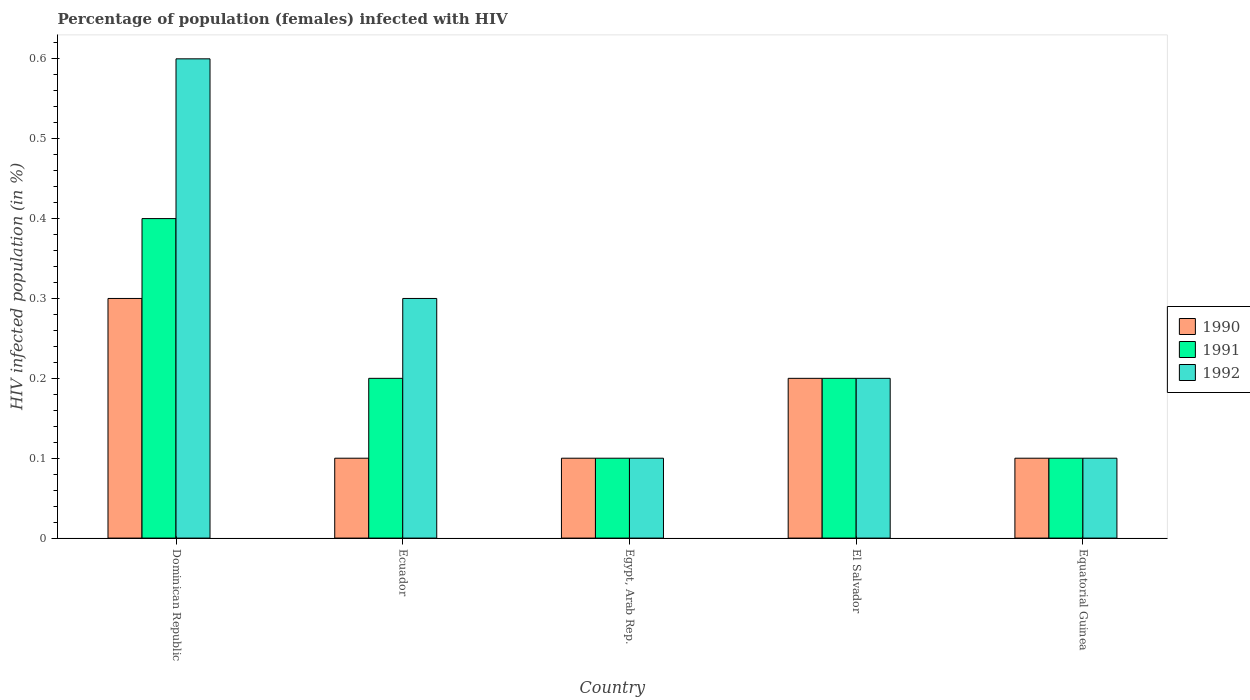How many different coloured bars are there?
Keep it short and to the point. 3. Are the number of bars on each tick of the X-axis equal?
Keep it short and to the point. Yes. What is the label of the 3rd group of bars from the left?
Provide a short and direct response. Egypt, Arab Rep. In how many cases, is the number of bars for a given country not equal to the number of legend labels?
Provide a short and direct response. 0. What is the percentage of HIV infected female population in 1990 in El Salvador?
Ensure brevity in your answer.  0.2. Across all countries, what is the maximum percentage of HIV infected female population in 1991?
Ensure brevity in your answer.  0.4. In which country was the percentage of HIV infected female population in 1990 maximum?
Provide a succinct answer. Dominican Republic. In which country was the percentage of HIV infected female population in 1992 minimum?
Provide a short and direct response. Egypt, Arab Rep. What is the difference between the percentage of HIV infected female population in 1991 in Dominican Republic and that in Ecuador?
Provide a succinct answer. 0.2. What is the difference between the percentage of HIV infected female population in 1991 in El Salvador and the percentage of HIV infected female population in 1992 in Dominican Republic?
Provide a short and direct response. -0.4. What is the average percentage of HIV infected female population in 1992 per country?
Offer a terse response. 0.26. What is the difference between the percentage of HIV infected female population of/in 1991 and percentage of HIV infected female population of/in 1992 in Dominican Republic?
Keep it short and to the point. -0.2. What is the ratio of the percentage of HIV infected female population in 1992 in Dominican Republic to that in Egypt, Arab Rep.?
Provide a succinct answer. 6. Is the percentage of HIV infected female population in 1990 in El Salvador less than that in Equatorial Guinea?
Your answer should be compact. No. What is the difference between the highest and the lowest percentage of HIV infected female population in 1991?
Your answer should be very brief. 0.3. In how many countries, is the percentage of HIV infected female population in 1991 greater than the average percentage of HIV infected female population in 1991 taken over all countries?
Provide a short and direct response. 1. Is it the case that in every country, the sum of the percentage of HIV infected female population in 1992 and percentage of HIV infected female population in 1991 is greater than the percentage of HIV infected female population in 1990?
Provide a succinct answer. Yes. How many bars are there?
Ensure brevity in your answer.  15. Are all the bars in the graph horizontal?
Your response must be concise. No. Are the values on the major ticks of Y-axis written in scientific E-notation?
Ensure brevity in your answer.  No. How are the legend labels stacked?
Your answer should be very brief. Vertical. What is the title of the graph?
Your answer should be very brief. Percentage of population (females) infected with HIV. Does "1964" appear as one of the legend labels in the graph?
Provide a short and direct response. No. What is the label or title of the Y-axis?
Ensure brevity in your answer.  HIV infected population (in %). What is the HIV infected population (in %) of 1990 in Dominican Republic?
Give a very brief answer. 0.3. What is the HIV infected population (in %) of 1992 in Ecuador?
Give a very brief answer. 0.3. What is the HIV infected population (in %) of 1990 in Egypt, Arab Rep.?
Provide a succinct answer. 0.1. What is the HIV infected population (in %) in 1991 in Egypt, Arab Rep.?
Your answer should be very brief. 0.1. What is the HIV infected population (in %) in 1992 in Egypt, Arab Rep.?
Your response must be concise. 0.1. What is the HIV infected population (in %) in 1990 in El Salvador?
Make the answer very short. 0.2. What is the HIV infected population (in %) of 1991 in El Salvador?
Your response must be concise. 0.2. What is the HIV infected population (in %) in 1992 in Equatorial Guinea?
Ensure brevity in your answer.  0.1. Across all countries, what is the maximum HIV infected population (in %) in 1990?
Ensure brevity in your answer.  0.3. Across all countries, what is the maximum HIV infected population (in %) of 1991?
Offer a terse response. 0.4. Across all countries, what is the minimum HIV infected population (in %) in 1990?
Provide a succinct answer. 0.1. Across all countries, what is the minimum HIV infected population (in %) of 1992?
Your response must be concise. 0.1. What is the total HIV infected population (in %) of 1990 in the graph?
Your answer should be very brief. 0.8. What is the total HIV infected population (in %) of 1992 in the graph?
Your response must be concise. 1.3. What is the difference between the HIV infected population (in %) in 1991 in Dominican Republic and that in Egypt, Arab Rep.?
Give a very brief answer. 0.3. What is the difference between the HIV infected population (in %) of 1992 in Dominican Republic and that in Egypt, Arab Rep.?
Keep it short and to the point. 0.5. What is the difference between the HIV infected population (in %) in 1992 in Dominican Republic and that in El Salvador?
Your answer should be compact. 0.4. What is the difference between the HIV infected population (in %) of 1991 in Dominican Republic and that in Equatorial Guinea?
Your answer should be compact. 0.3. What is the difference between the HIV infected population (in %) in 1990 in Ecuador and that in El Salvador?
Keep it short and to the point. -0.1. What is the difference between the HIV infected population (in %) in 1990 in Ecuador and that in Equatorial Guinea?
Offer a terse response. 0. What is the difference between the HIV infected population (in %) in 1990 in Egypt, Arab Rep. and that in El Salvador?
Offer a terse response. -0.1. What is the difference between the HIV infected population (in %) of 1991 in Egypt, Arab Rep. and that in El Salvador?
Offer a terse response. -0.1. What is the difference between the HIV infected population (in %) of 1991 in Egypt, Arab Rep. and that in Equatorial Guinea?
Give a very brief answer. 0. What is the difference between the HIV infected population (in %) of 1990 in El Salvador and that in Equatorial Guinea?
Your answer should be compact. 0.1. What is the difference between the HIV infected population (in %) in 1991 in El Salvador and that in Equatorial Guinea?
Give a very brief answer. 0.1. What is the difference between the HIV infected population (in %) of 1992 in El Salvador and that in Equatorial Guinea?
Your answer should be compact. 0.1. What is the difference between the HIV infected population (in %) in 1990 in Dominican Republic and the HIV infected population (in %) in 1991 in Egypt, Arab Rep.?
Keep it short and to the point. 0.2. What is the difference between the HIV infected population (in %) of 1991 in Dominican Republic and the HIV infected population (in %) of 1992 in Egypt, Arab Rep.?
Your response must be concise. 0.3. What is the difference between the HIV infected population (in %) in 1990 in Dominican Republic and the HIV infected population (in %) in 1991 in El Salvador?
Provide a short and direct response. 0.1. What is the difference between the HIV infected population (in %) in 1990 in Dominican Republic and the HIV infected population (in %) in 1992 in El Salvador?
Offer a very short reply. 0.1. What is the difference between the HIV infected population (in %) of 1991 in Dominican Republic and the HIV infected population (in %) of 1992 in El Salvador?
Your response must be concise. 0.2. What is the difference between the HIV infected population (in %) of 1990 in Dominican Republic and the HIV infected population (in %) of 1991 in Equatorial Guinea?
Provide a succinct answer. 0.2. What is the difference between the HIV infected population (in %) in 1991 in Dominican Republic and the HIV infected population (in %) in 1992 in Equatorial Guinea?
Your answer should be compact. 0.3. What is the difference between the HIV infected population (in %) in 1990 in Ecuador and the HIV infected population (in %) in 1991 in Egypt, Arab Rep.?
Your answer should be very brief. 0. What is the difference between the HIV infected population (in %) in 1991 in Ecuador and the HIV infected population (in %) in 1992 in El Salvador?
Your answer should be very brief. 0. What is the difference between the HIV infected population (in %) of 1990 in Ecuador and the HIV infected population (in %) of 1992 in Equatorial Guinea?
Give a very brief answer. 0. What is the difference between the HIV infected population (in %) of 1991 in Ecuador and the HIV infected population (in %) of 1992 in Equatorial Guinea?
Offer a very short reply. 0.1. What is the difference between the HIV infected population (in %) in 1990 in Egypt, Arab Rep. and the HIV infected population (in %) in 1992 in El Salvador?
Your answer should be very brief. -0.1. What is the difference between the HIV infected population (in %) of 1991 in Egypt, Arab Rep. and the HIV infected population (in %) of 1992 in El Salvador?
Provide a succinct answer. -0.1. What is the difference between the HIV infected population (in %) in 1990 in Egypt, Arab Rep. and the HIV infected population (in %) in 1991 in Equatorial Guinea?
Keep it short and to the point. 0. What is the difference between the HIV infected population (in %) of 1990 in Egypt, Arab Rep. and the HIV infected population (in %) of 1992 in Equatorial Guinea?
Make the answer very short. 0. What is the difference between the HIV infected population (in %) in 1990 in El Salvador and the HIV infected population (in %) in 1992 in Equatorial Guinea?
Ensure brevity in your answer.  0.1. What is the average HIV infected population (in %) in 1990 per country?
Your response must be concise. 0.16. What is the average HIV infected population (in %) in 1991 per country?
Offer a very short reply. 0.2. What is the average HIV infected population (in %) in 1992 per country?
Your answer should be very brief. 0.26. What is the difference between the HIV infected population (in %) of 1990 and HIV infected population (in %) of 1991 in Dominican Republic?
Provide a succinct answer. -0.1. What is the difference between the HIV infected population (in %) in 1991 and HIV infected population (in %) in 1992 in Dominican Republic?
Your answer should be compact. -0.2. What is the difference between the HIV infected population (in %) of 1990 and HIV infected population (in %) of 1991 in Ecuador?
Offer a terse response. -0.1. What is the difference between the HIV infected population (in %) of 1990 and HIV infected population (in %) of 1991 in Egypt, Arab Rep.?
Provide a short and direct response. 0. What is the difference between the HIV infected population (in %) of 1990 and HIV infected population (in %) of 1992 in Egypt, Arab Rep.?
Provide a succinct answer. 0. What is the difference between the HIV infected population (in %) of 1991 and HIV infected population (in %) of 1992 in Egypt, Arab Rep.?
Offer a terse response. 0. What is the difference between the HIV infected population (in %) of 1990 and HIV infected population (in %) of 1991 in El Salvador?
Keep it short and to the point. 0. What is the difference between the HIV infected population (in %) of 1991 and HIV infected population (in %) of 1992 in El Salvador?
Keep it short and to the point. 0. What is the difference between the HIV infected population (in %) in 1990 and HIV infected population (in %) in 1992 in Equatorial Guinea?
Keep it short and to the point. 0. What is the difference between the HIV infected population (in %) in 1991 and HIV infected population (in %) in 1992 in Equatorial Guinea?
Your answer should be compact. 0. What is the ratio of the HIV infected population (in %) in 1991 in Dominican Republic to that in Ecuador?
Keep it short and to the point. 2. What is the ratio of the HIV infected population (in %) in 1992 in Dominican Republic to that in Ecuador?
Ensure brevity in your answer.  2. What is the ratio of the HIV infected population (in %) of 1990 in Dominican Republic to that in Egypt, Arab Rep.?
Provide a short and direct response. 3. What is the ratio of the HIV infected population (in %) in 1991 in Dominican Republic to that in Egypt, Arab Rep.?
Your answer should be compact. 4. What is the ratio of the HIV infected population (in %) of 1992 in Dominican Republic to that in El Salvador?
Provide a succinct answer. 3. What is the ratio of the HIV infected population (in %) of 1992 in Dominican Republic to that in Equatorial Guinea?
Keep it short and to the point. 6. What is the ratio of the HIV infected population (in %) in 1991 in Ecuador to that in El Salvador?
Ensure brevity in your answer.  1. What is the ratio of the HIV infected population (in %) in 1992 in Ecuador to that in Equatorial Guinea?
Provide a succinct answer. 3. What is the ratio of the HIV infected population (in %) of 1991 in Egypt, Arab Rep. to that in El Salvador?
Ensure brevity in your answer.  0.5. What is the ratio of the HIV infected population (in %) of 1992 in Egypt, Arab Rep. to that in El Salvador?
Your response must be concise. 0.5. What is the ratio of the HIV infected population (in %) in 1990 in Egypt, Arab Rep. to that in Equatorial Guinea?
Ensure brevity in your answer.  1. What is the ratio of the HIV infected population (in %) of 1992 in Egypt, Arab Rep. to that in Equatorial Guinea?
Make the answer very short. 1. What is the ratio of the HIV infected population (in %) of 1990 in El Salvador to that in Equatorial Guinea?
Ensure brevity in your answer.  2. What is the ratio of the HIV infected population (in %) in 1991 in El Salvador to that in Equatorial Guinea?
Make the answer very short. 2. What is the difference between the highest and the second highest HIV infected population (in %) of 1990?
Make the answer very short. 0.1. What is the difference between the highest and the second highest HIV infected population (in %) in 1992?
Provide a short and direct response. 0.3. What is the difference between the highest and the lowest HIV infected population (in %) of 1990?
Give a very brief answer. 0.2. What is the difference between the highest and the lowest HIV infected population (in %) of 1991?
Provide a succinct answer. 0.3. What is the difference between the highest and the lowest HIV infected population (in %) of 1992?
Ensure brevity in your answer.  0.5. 